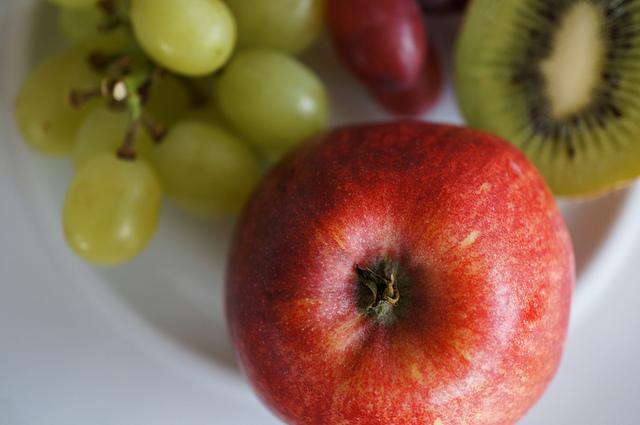What is this food?
Short answer required. Fruit. What is the apple sitting on?
Be succinct. Plate. Is this a healthy thing to eat?
Quick response, please. Yes. What kind of fruits are on the table?
Answer briefly. Apple grapes kiwi. Is the apple red?
Answer briefly. Yes. Would you like to eat this apple?
Short answer required. Yes. How many different types of fruit are in the image?
Write a very short answer. 3. 